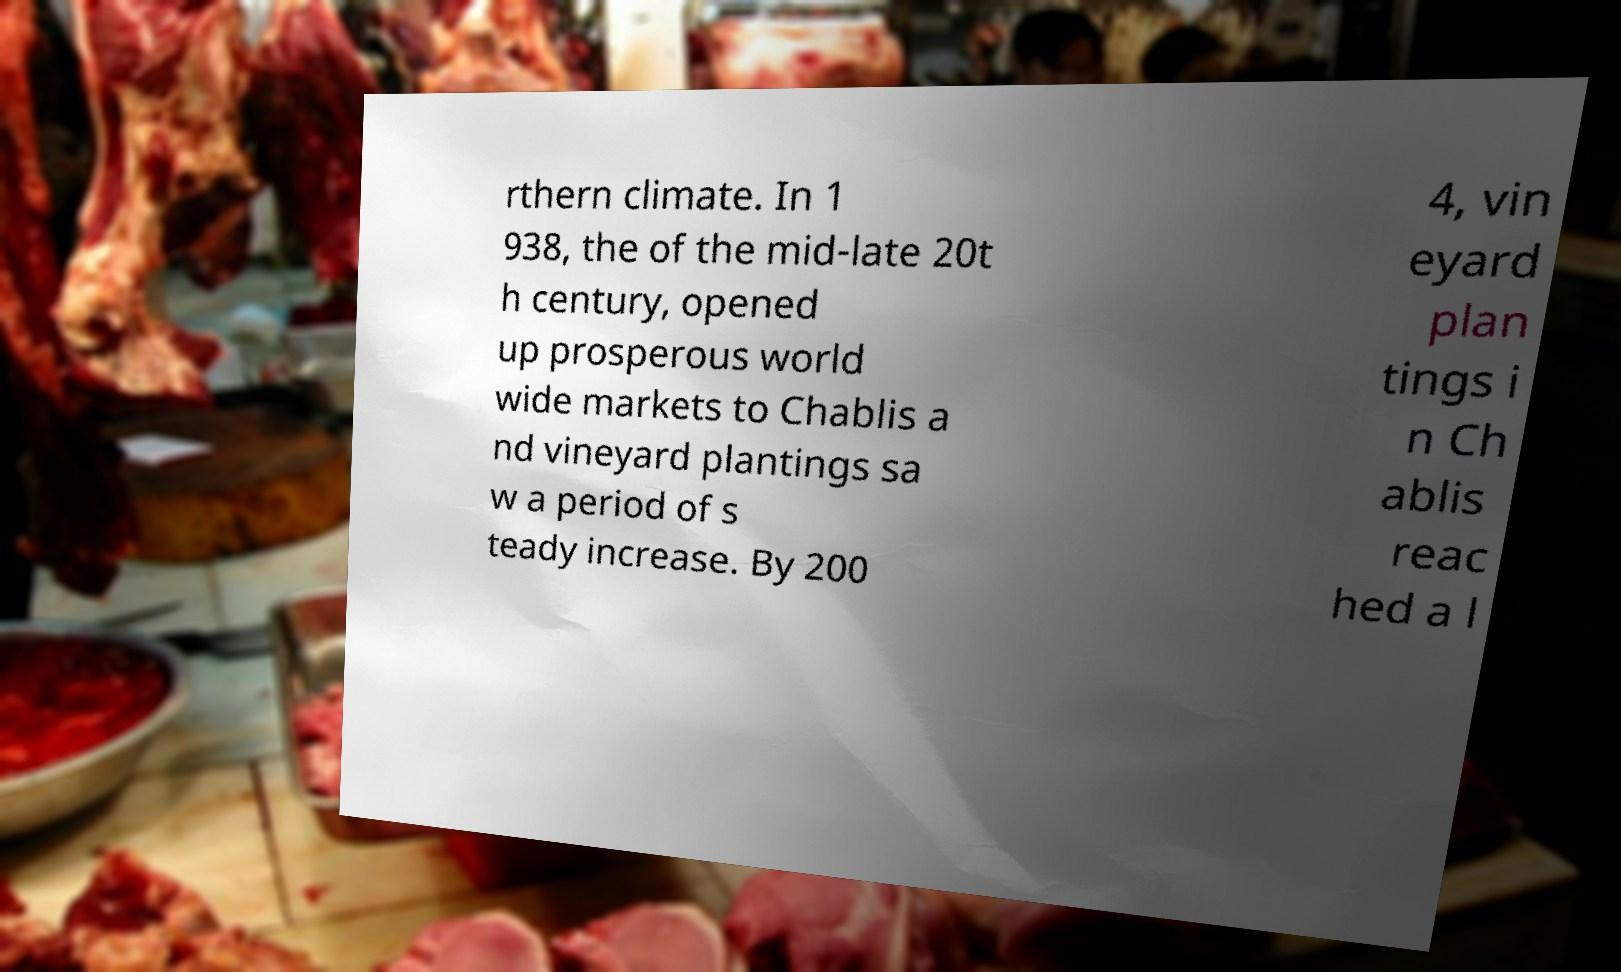Can you accurately transcribe the text from the provided image for me? rthern climate. In 1 938, the of the mid-late 20t h century, opened up prosperous world wide markets to Chablis a nd vineyard plantings sa w a period of s teady increase. By 200 4, vin eyard plan tings i n Ch ablis reac hed a l 